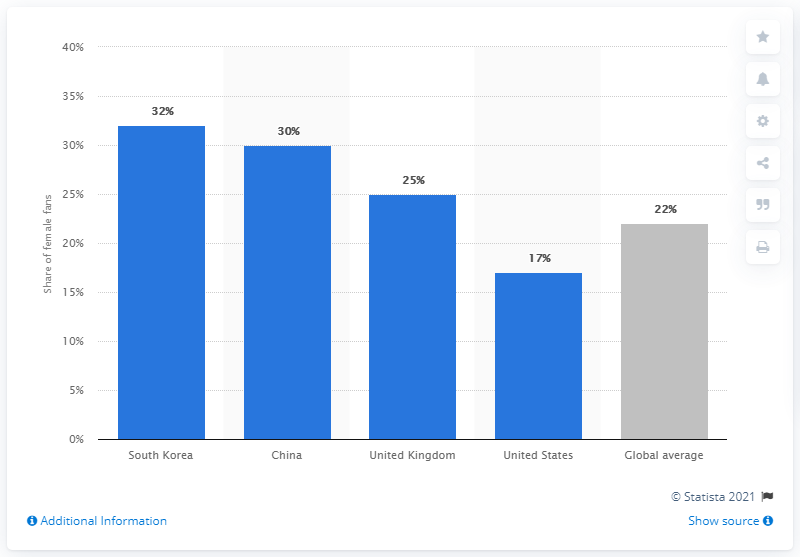Draw attention to some important aspects in this diagram. According to recent estimates, only 22% of eSports fans worldwide are female. 